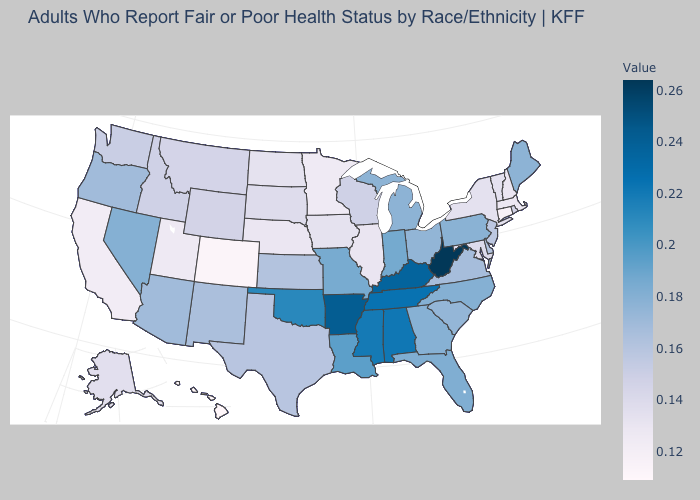Does the map have missing data?
Be succinct. No. Is the legend a continuous bar?
Short answer required. Yes. Is the legend a continuous bar?
Keep it brief. Yes. Which states have the lowest value in the USA?
Be succinct. Hawaii. Does the map have missing data?
Write a very short answer. No. 